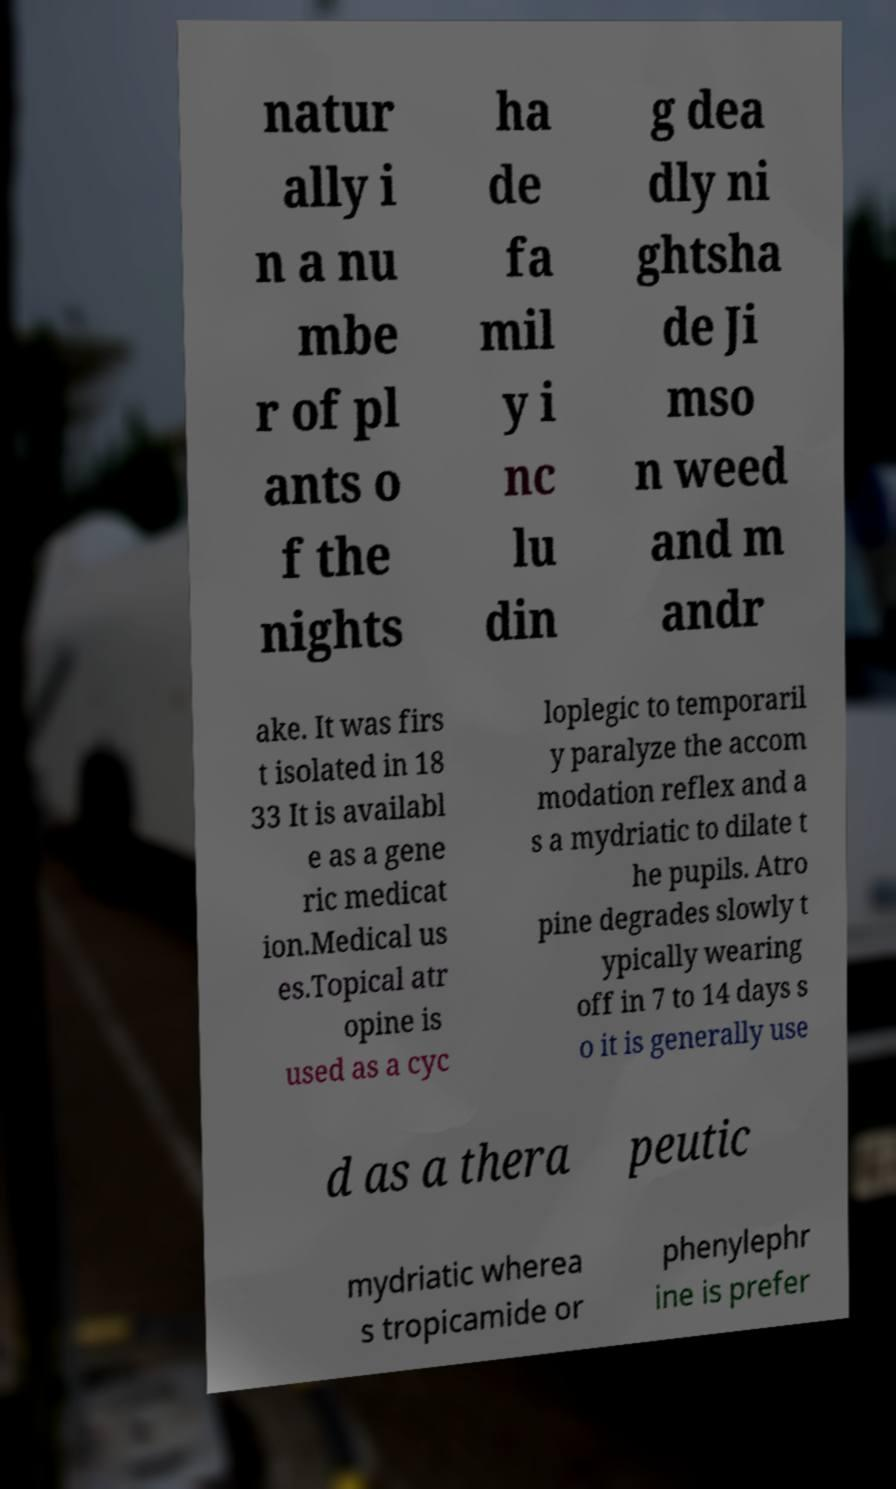Please read and relay the text visible in this image. What does it say? natur ally i n a nu mbe r of pl ants o f the nights ha de fa mil y i nc lu din g dea dly ni ghtsha de Ji mso n weed and m andr ake. It was firs t isolated in 18 33 It is availabl e as a gene ric medicat ion.Medical us es.Topical atr opine is used as a cyc loplegic to temporaril y paralyze the accom modation reflex and a s a mydriatic to dilate t he pupils. Atro pine degrades slowly t ypically wearing off in 7 to 14 days s o it is generally use d as a thera peutic mydriatic wherea s tropicamide or phenylephr ine is prefer 